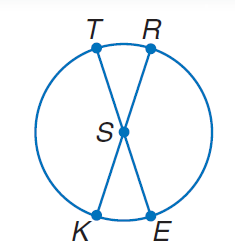Answer the mathemtical geometry problem and directly provide the correct option letter.
Question: In \odot S, m \angle T S R = 42. Find m \widehat K T.
Choices: A: 21 B: 42 C: 63 D: 138 D 